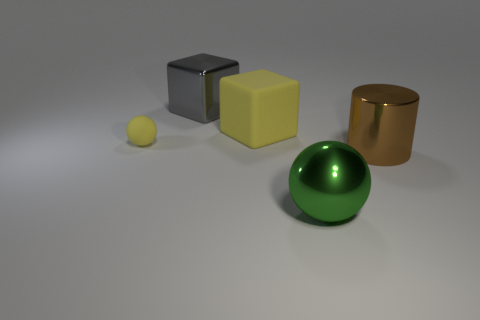Add 1 small green matte cylinders. How many objects exist? 6 Subtract all spheres. How many objects are left? 3 Subtract all cyan blocks. Subtract all green cylinders. How many blocks are left? 2 Subtract all small yellow balls. Subtract all small green rubber spheres. How many objects are left? 4 Add 2 small things. How many small things are left? 3 Add 3 big gray blocks. How many big gray blocks exist? 4 Subtract 0 brown cubes. How many objects are left? 5 